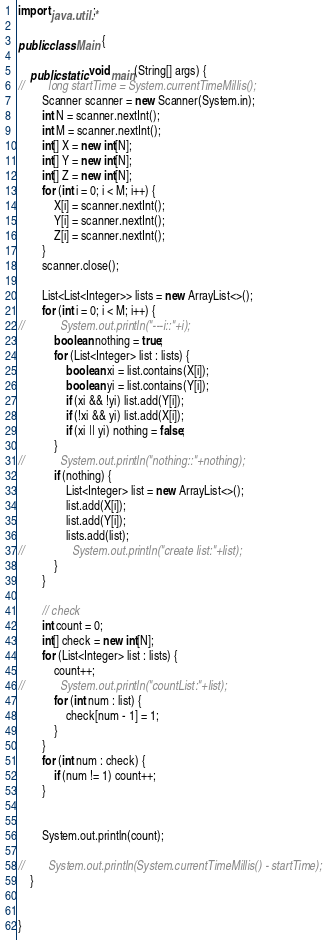<code> <loc_0><loc_0><loc_500><loc_500><_Java_>import java.util.*;

public class Main {

    public static void main(String[] args) {
//        long startTime = System.currentTimeMillis();
        Scanner scanner = new Scanner(System.in);
        int N = scanner.nextInt();
        int M = scanner.nextInt();
        int[] X = new int[N];
        int[] Y = new int[N];
        int[] Z = new int[N];
        for (int i = 0; i < M; i++) {
            X[i] = scanner.nextInt();
            Y[i] = scanner.nextInt();
            Z[i] = scanner.nextInt();
        }
        scanner.close();

        List<List<Integer>> lists = new ArrayList<>();
        for (int i = 0; i < M; i++) {
//            System.out.println("---i::"+i);
            boolean nothing = true;
            for (List<Integer> list : lists) {
                boolean xi = list.contains(X[i]);
                boolean yi = list.contains(Y[i]);
                if (xi && !yi) list.add(Y[i]);
                if (!xi && yi) list.add(X[i]);
                if (xi || yi) nothing = false;
            }
//            System.out.println("nothing::"+nothing);
            if (nothing) {
                List<Integer> list = new ArrayList<>();
                list.add(X[i]);
                list.add(Y[i]);
                lists.add(list);
//                System.out.println("create list:"+list);
            }
        }

        // check
        int count = 0;
        int[] check = new int[N];
        for (List<Integer> list : lists) {
            count++;
//            System.out.println("countList:"+list);
            for (int num : list) {
                check[num - 1] = 1;
            }
        }
        for (int num : check) {
            if (num != 1) count++;
        }


        System.out.println(count);

//        System.out.println(System.currentTimeMillis() - startTime);
    }


}
</code> 